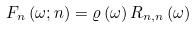Convert formula to latex. <formula><loc_0><loc_0><loc_500><loc_500>F _ { n } \left ( \omega ; n \right ) = \varrho \left ( \omega \right ) R _ { n , n } \left ( \omega \right )</formula> 